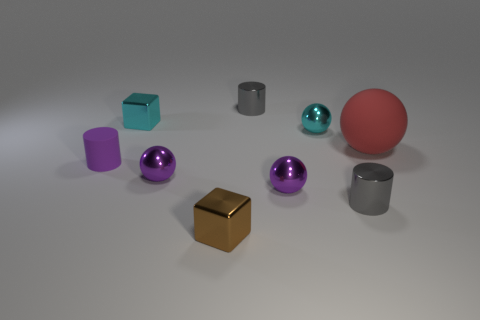How many metallic balls have the same color as the tiny rubber thing?
Offer a terse response. 2. There is a small block that is on the left side of the small brown metal cube; is its color the same as the rubber object in front of the big red matte object?
Offer a terse response. No. Is the big matte object the same shape as the small brown object?
Offer a terse response. No. Is there anything else that has the same shape as the large red matte object?
Keep it short and to the point. Yes. Are the gray thing that is in front of the tiny cyan metal ball and the tiny brown object made of the same material?
Ensure brevity in your answer.  Yes. There is a thing that is behind the small cyan sphere and on the right side of the brown thing; what shape is it?
Provide a succinct answer. Cylinder. Is there a small gray metal object behind the metallic sphere behind the red rubber sphere?
Provide a short and direct response. Yes. What number of other things are there of the same material as the tiny cyan ball
Your answer should be compact. 6. There is a matte object on the left side of the red matte sphere; does it have the same shape as the red matte thing that is behind the small purple matte cylinder?
Provide a short and direct response. No. Is the cyan cube made of the same material as the big thing?
Offer a terse response. No. 